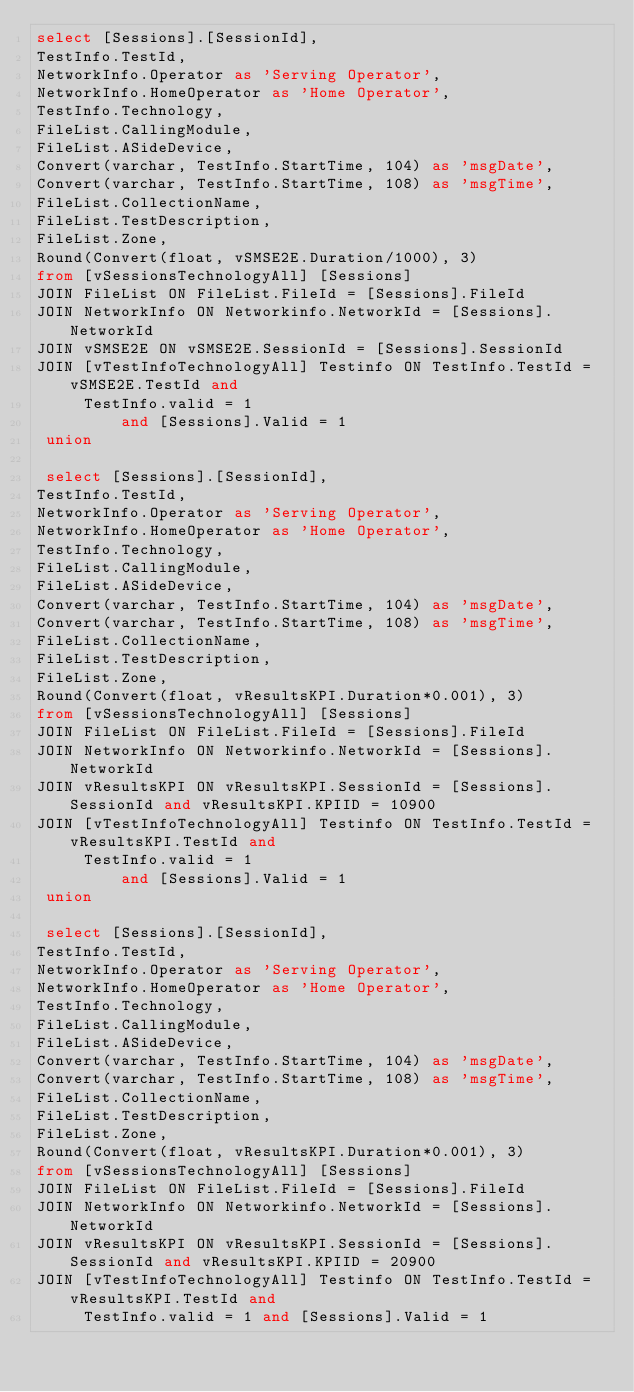Convert code to text. <code><loc_0><loc_0><loc_500><loc_500><_SQL_>select [Sessions].[SessionId], 
TestInfo.TestId, 
NetworkInfo.Operator as 'Serving Operator', 
NetworkInfo.HomeOperator as 'Home Operator', 
TestInfo.Technology, 
FileList.CallingModule, 
FileList.ASideDevice, 
Convert(varchar, TestInfo.StartTime, 104) as 'msgDate', 
Convert(varchar, TestInfo.StartTime, 108) as 'msgTime', 
FileList.CollectionName, 
FileList.TestDescription, 
FileList.Zone, 
Round(Convert(float, vSMSE2E.Duration/1000), 3)
from [vSessionsTechnologyAll] [Sessions]
JOIN FileList ON FileList.FileId = [Sessions].FileId
JOIN NetworkInfo ON Networkinfo.NetworkId = [Sessions].NetworkId
JOIN vSMSE2E ON vSMSE2E.SessionId = [Sessions].SessionId
JOIN [vTestInfoTechnologyAll] Testinfo ON TestInfo.TestId = vSMSE2E.TestId and 
     TestInfo.valid = 1
		 and [Sessions].Valid = 1
 union 
 
 select [Sessions].[SessionId], 
TestInfo.TestId, 
NetworkInfo.Operator as 'Serving Operator', 
NetworkInfo.HomeOperator as 'Home Operator', 
TestInfo.Technology, 
FileList.CallingModule, 
FileList.ASideDevice, 
Convert(varchar, TestInfo.StartTime, 104) as 'msgDate', 
Convert(varchar, TestInfo.StartTime, 108) as 'msgTime', 
FileList.CollectionName, 
FileList.TestDescription, 
FileList.Zone, 
Round(Convert(float, vResultsKPI.Duration*0.001), 3)
from [vSessionsTechnologyAll] [Sessions]
JOIN FileList ON FileList.FileId = [Sessions].FileId
JOIN NetworkInfo ON Networkinfo.NetworkId = [Sessions].NetworkId
JOIN vResultsKPI ON vResultsKPI.SessionId = [Sessions].SessionId and vResultsKPI.KPIID = 10900
JOIN [vTestInfoTechnologyAll] Testinfo ON TestInfo.TestId = vResultsKPI.TestId and 
     TestInfo.valid = 1
		 and [Sessions].Valid = 1 
 union 
 
 select [Sessions].[SessionId], 
TestInfo.TestId, 
NetworkInfo.Operator as 'Serving Operator', 
NetworkInfo.HomeOperator as 'Home Operator', 
TestInfo.Technology, 
FileList.CallingModule, 
FileList.ASideDevice, 
Convert(varchar, TestInfo.StartTime, 104) as 'msgDate', 
Convert(varchar, TestInfo.StartTime, 108) as 'msgTime', 
FileList.CollectionName, 
FileList.TestDescription, 
FileList.Zone, 
Round(Convert(float, vResultsKPI.Duration*0.001), 3)
from [vSessionsTechnologyAll] [Sessions]
JOIN FileList ON FileList.FileId = [Sessions].FileId
JOIN NetworkInfo ON Networkinfo.NetworkId = [Sessions].NetworkId
JOIN vResultsKPI ON vResultsKPI.SessionId = [Sessions].SessionId and vResultsKPI.KPIID = 20900
JOIN [vTestInfoTechnologyAll] Testinfo ON TestInfo.TestId = vResultsKPI.TestId and 
     TestInfo.valid = 1 and [Sessions].Valid = 1 </code> 